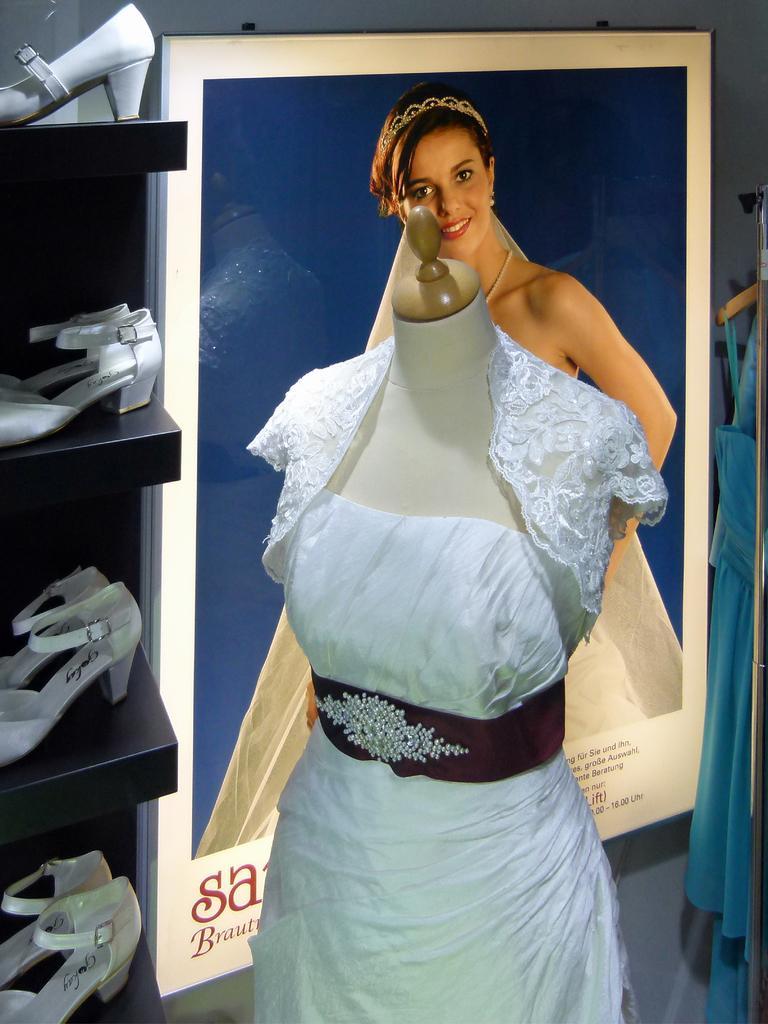Please provide a concise description of this image. In this image we can see there is a mannequin wearing white dress, behind that there is a photo frame on the wall, also there is a shelf with white foot wear. 